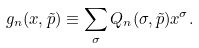Convert formula to latex. <formula><loc_0><loc_0><loc_500><loc_500>g _ { n } ( x , \tilde { p } ) \equiv \sum _ { \sigma } Q _ { n } ( \sigma , \tilde { p } ) x ^ { \sigma } .</formula> 